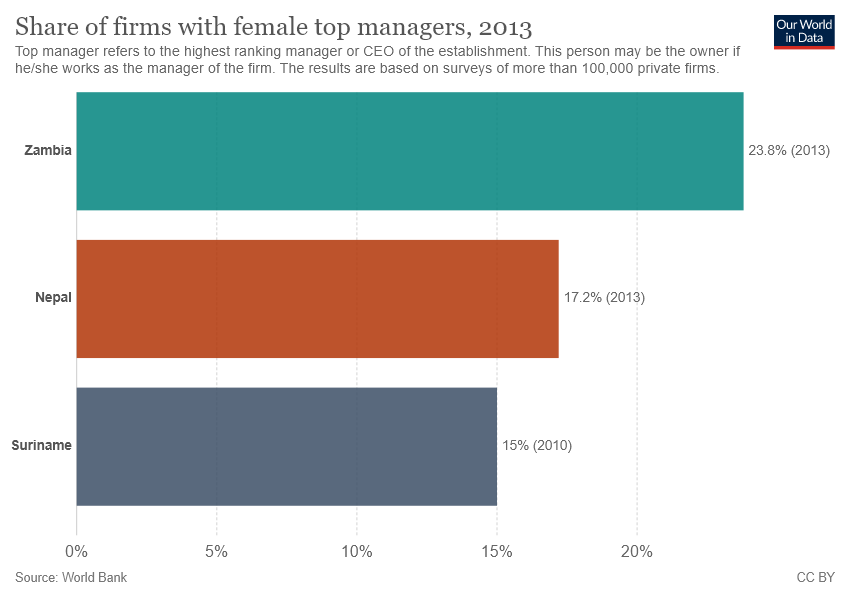Outline some significant characteristics in this image. Nepal is represented by a brown bar. The sum of Nepal and Suriname is greater than the value of Zambia. 